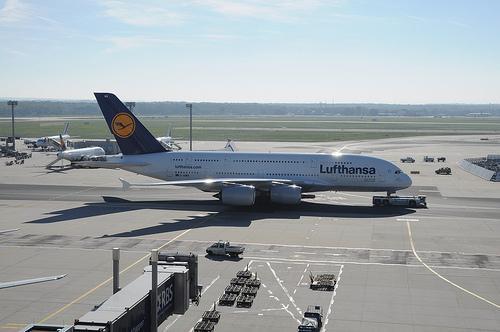How many airplanes are in the photo?
Give a very brief answer. 1. 